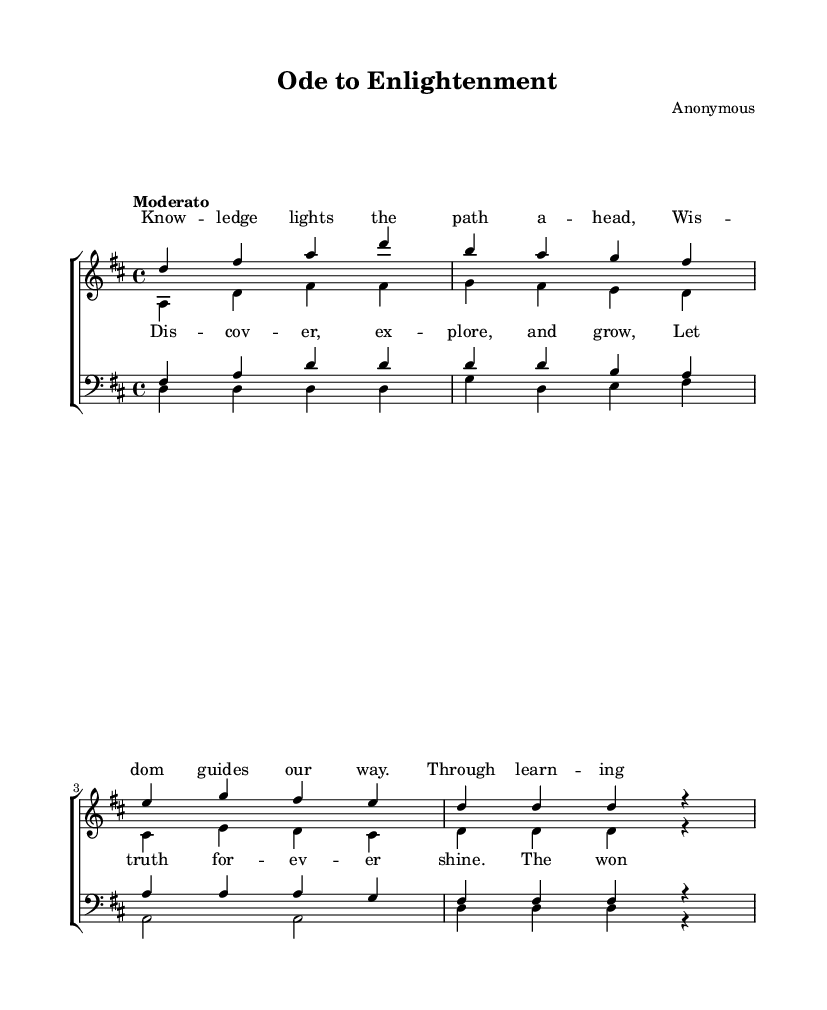What is the key signature of this music? The key signature is indicated on the staff at the beginning of the music and shows two sharps (F# and C#). This defines the piece as being in D major.
Answer: D major What is the time signature of this music? The time signature is found at the beginning of the music, shown as a fraction. In this case, it is 4/4, meaning there are four beats in each measure and the quarter note gets one beat.
Answer: 4/4 What is the tempo marking for this piece? The tempo marking is typically located above the staff in the Italian language. Here, it is marked “Moderato,” which indicates a moderate speed for the music.
Answer: Moderato How many measures are in the soprano music? By counting the vertical lines separating each measure, there are a total of four measures in the soprano part.
Answer: Four Which voice part begins with the note D? Observing the notes for all voice parts, the soprano and bass music both start with the note D in their first measure.
Answer: Soprano and bass What is the theme of the lyrics in the chorus? The theme can be discerned by reading the lyrics provided for the chorus, which celebrate discovery and knowledge. The text encourages exploration and alignment of hearts and minds.
Answer: Discovery and knowledge What type of ensemble is indicated by the score? The score is labeled as a ChoirStaff, indicating it is written for a choral ensemble, consisting of both soprano and tenor voices along with altos and basses.
Answer: Choir 